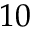<formula> <loc_0><loc_0><loc_500><loc_500>1 0</formula> 